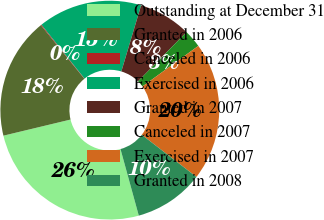Convert chart to OTSL. <chart><loc_0><loc_0><loc_500><loc_500><pie_chart><fcel>Outstanding at December 31<fcel>Granted in 2006<fcel>Canceled in 2006<fcel>Exercised in 2006<fcel>Granted in 2007<fcel>Canceled in 2007<fcel>Exercised in 2007<fcel>Granted in 2008<nl><fcel>25.52%<fcel>17.9%<fcel>0.11%<fcel>15.36%<fcel>7.74%<fcel>2.65%<fcel>20.44%<fcel>10.28%<nl></chart> 